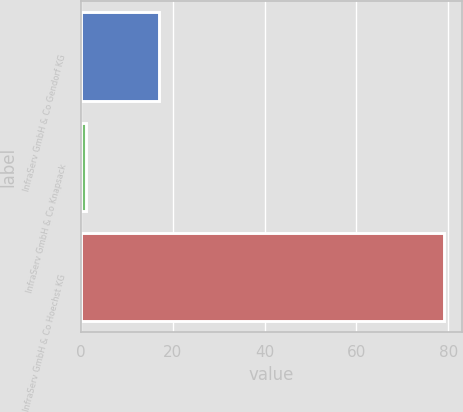Convert chart to OTSL. <chart><loc_0><loc_0><loc_500><loc_500><bar_chart><fcel>InfraServ GmbH & Co Gendorf KG<fcel>InfraServ GmbH & Co Knapsack<fcel>InfraServ GmbH & Co Hoechst KG<nl><fcel>17<fcel>1<fcel>79<nl></chart> 